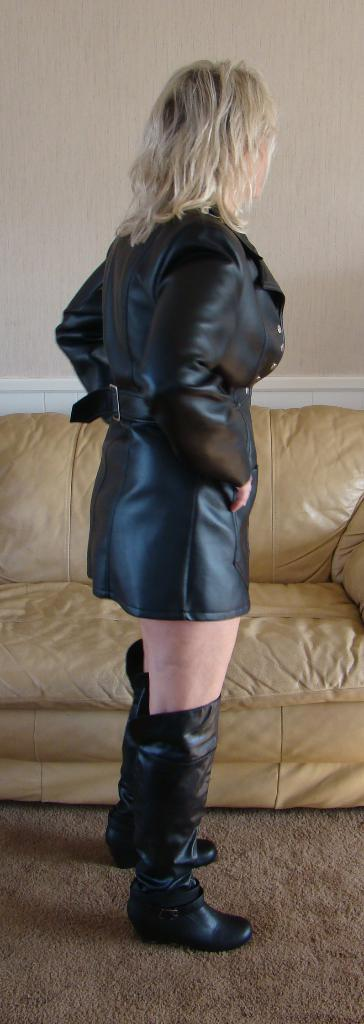Who is present in the image? There is a woman in the image. What is the woman doing in the image? The woman is standing. What is the woman wearing in the image? The woman is wearing a black dress. What type of furniture can be seen in the image? There is a couch in the image. What is visible in the background of the image? There is a wall in the background of the image. What type of calculator can be seen on the woman's hand in the image? There is no calculator present in the image, and the woman's hands are not visible. How many rabbits are hopping around the woman in the image? There are no rabbits present in the image. 